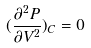<formula> <loc_0><loc_0><loc_500><loc_500>( \frac { \partial ^ { 2 } P } { \partial V ^ { 2 } } ) _ { C } = 0</formula> 